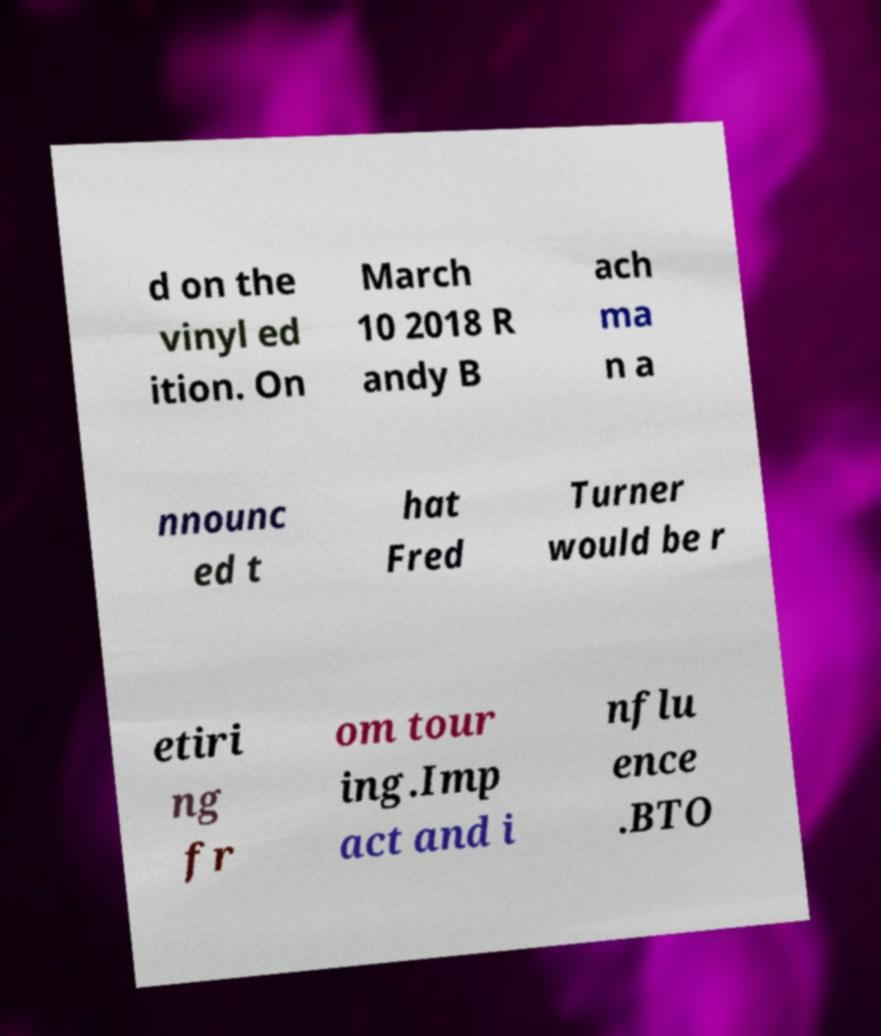Can you accurately transcribe the text from the provided image for me? d on the vinyl ed ition. On March 10 2018 R andy B ach ma n a nnounc ed t hat Fred Turner would be r etiri ng fr om tour ing.Imp act and i nflu ence .BTO 